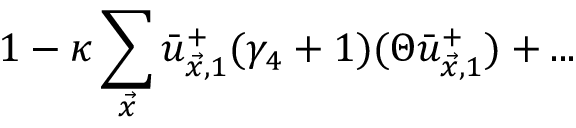Convert formula to latex. <formula><loc_0><loc_0><loc_500><loc_500>1 - \kappa \sum _ { \vec { x } } \bar { u } _ { \vec { x } , 1 } ^ { + } ( \gamma _ { 4 } + 1 ) ( \Theta \bar { u } _ { \vec { x } , 1 } ^ { + } ) + \dots</formula> 